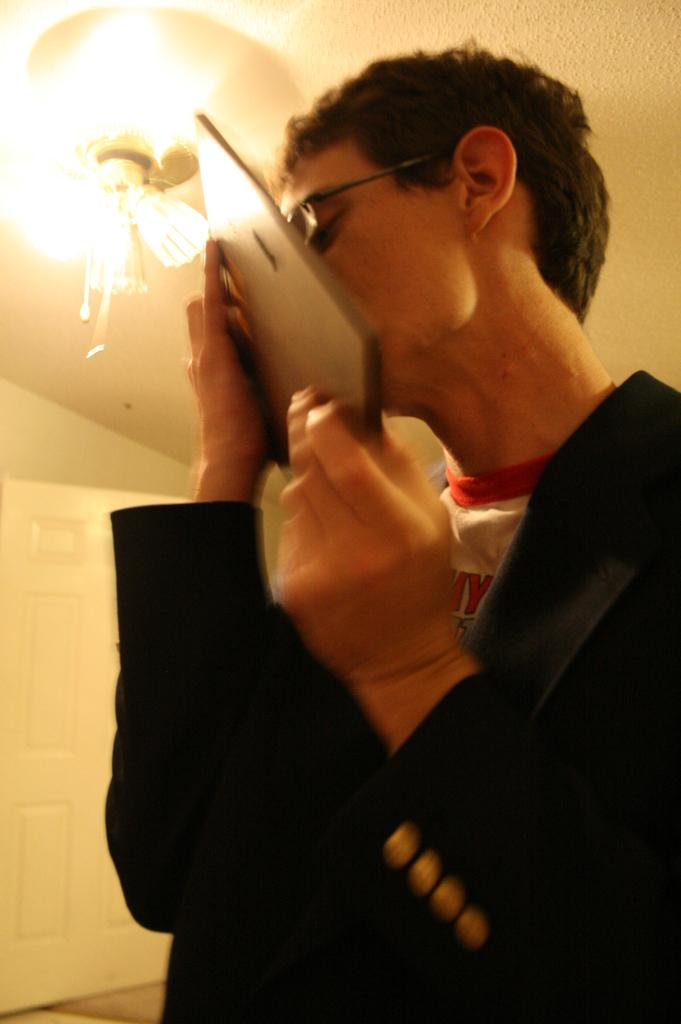What can be seen in the image related to a person? There is a person in the image. Can you describe the person's appearance? The person is wearing clothes and spectacles. What is the person holding in their hand? The person is holding an object in their hand. What architectural feature is present in the image? There is a door in the image. What is the lighting condition in the image? There is light in the image. What type of lead can be seen in the person's hand in the image? There is no lead present in the image; the person is holding an object, but it is not specified as lead. 